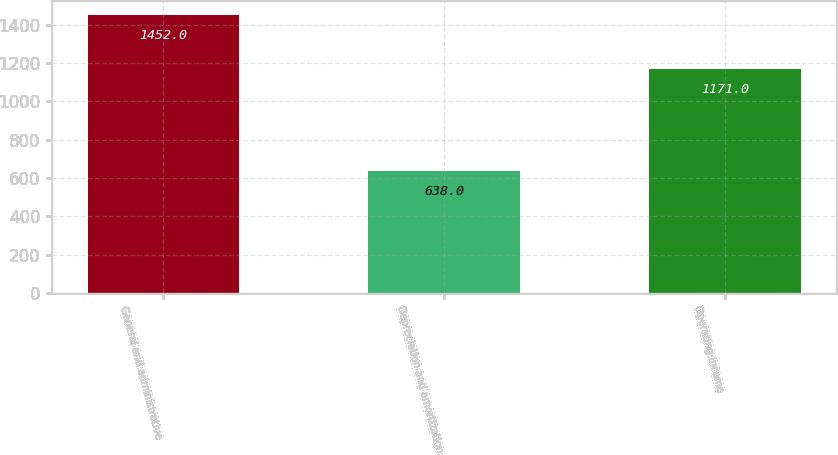Convert chart. <chart><loc_0><loc_0><loc_500><loc_500><bar_chart><fcel>General and administrative<fcel>Depreciation and amortization<fcel>Operating income<nl><fcel>1452<fcel>638<fcel>1171<nl></chart> 